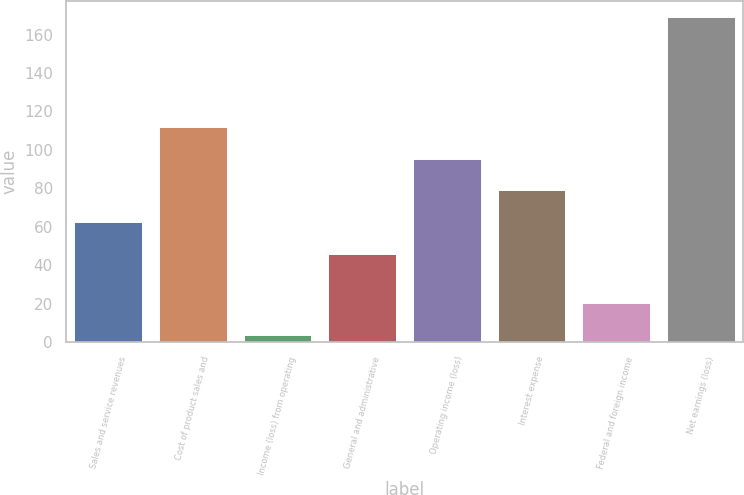Convert chart. <chart><loc_0><loc_0><loc_500><loc_500><bar_chart><fcel>Sales and service revenues<fcel>Cost of product sales and<fcel>Income (loss) from operating<fcel>General and administrative<fcel>Operating income (loss)<fcel>Interest expense<fcel>Federal and foreign income<fcel>Net earnings (loss)<nl><fcel>62.5<fcel>112<fcel>4<fcel>46<fcel>95.5<fcel>79<fcel>20.5<fcel>169<nl></chart> 